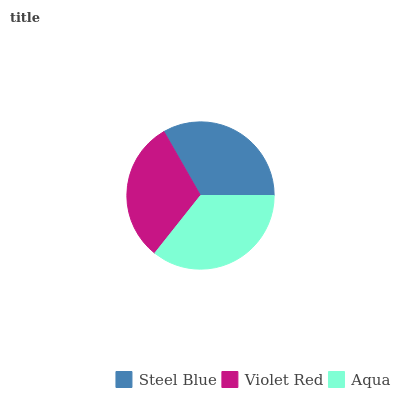Is Violet Red the minimum?
Answer yes or no. Yes. Is Aqua the maximum?
Answer yes or no. Yes. Is Aqua the minimum?
Answer yes or no. No. Is Violet Red the maximum?
Answer yes or no. No. Is Aqua greater than Violet Red?
Answer yes or no. Yes. Is Violet Red less than Aqua?
Answer yes or no. Yes. Is Violet Red greater than Aqua?
Answer yes or no. No. Is Aqua less than Violet Red?
Answer yes or no. No. Is Steel Blue the high median?
Answer yes or no. Yes. Is Steel Blue the low median?
Answer yes or no. Yes. Is Aqua the high median?
Answer yes or no. No. Is Aqua the low median?
Answer yes or no. No. 